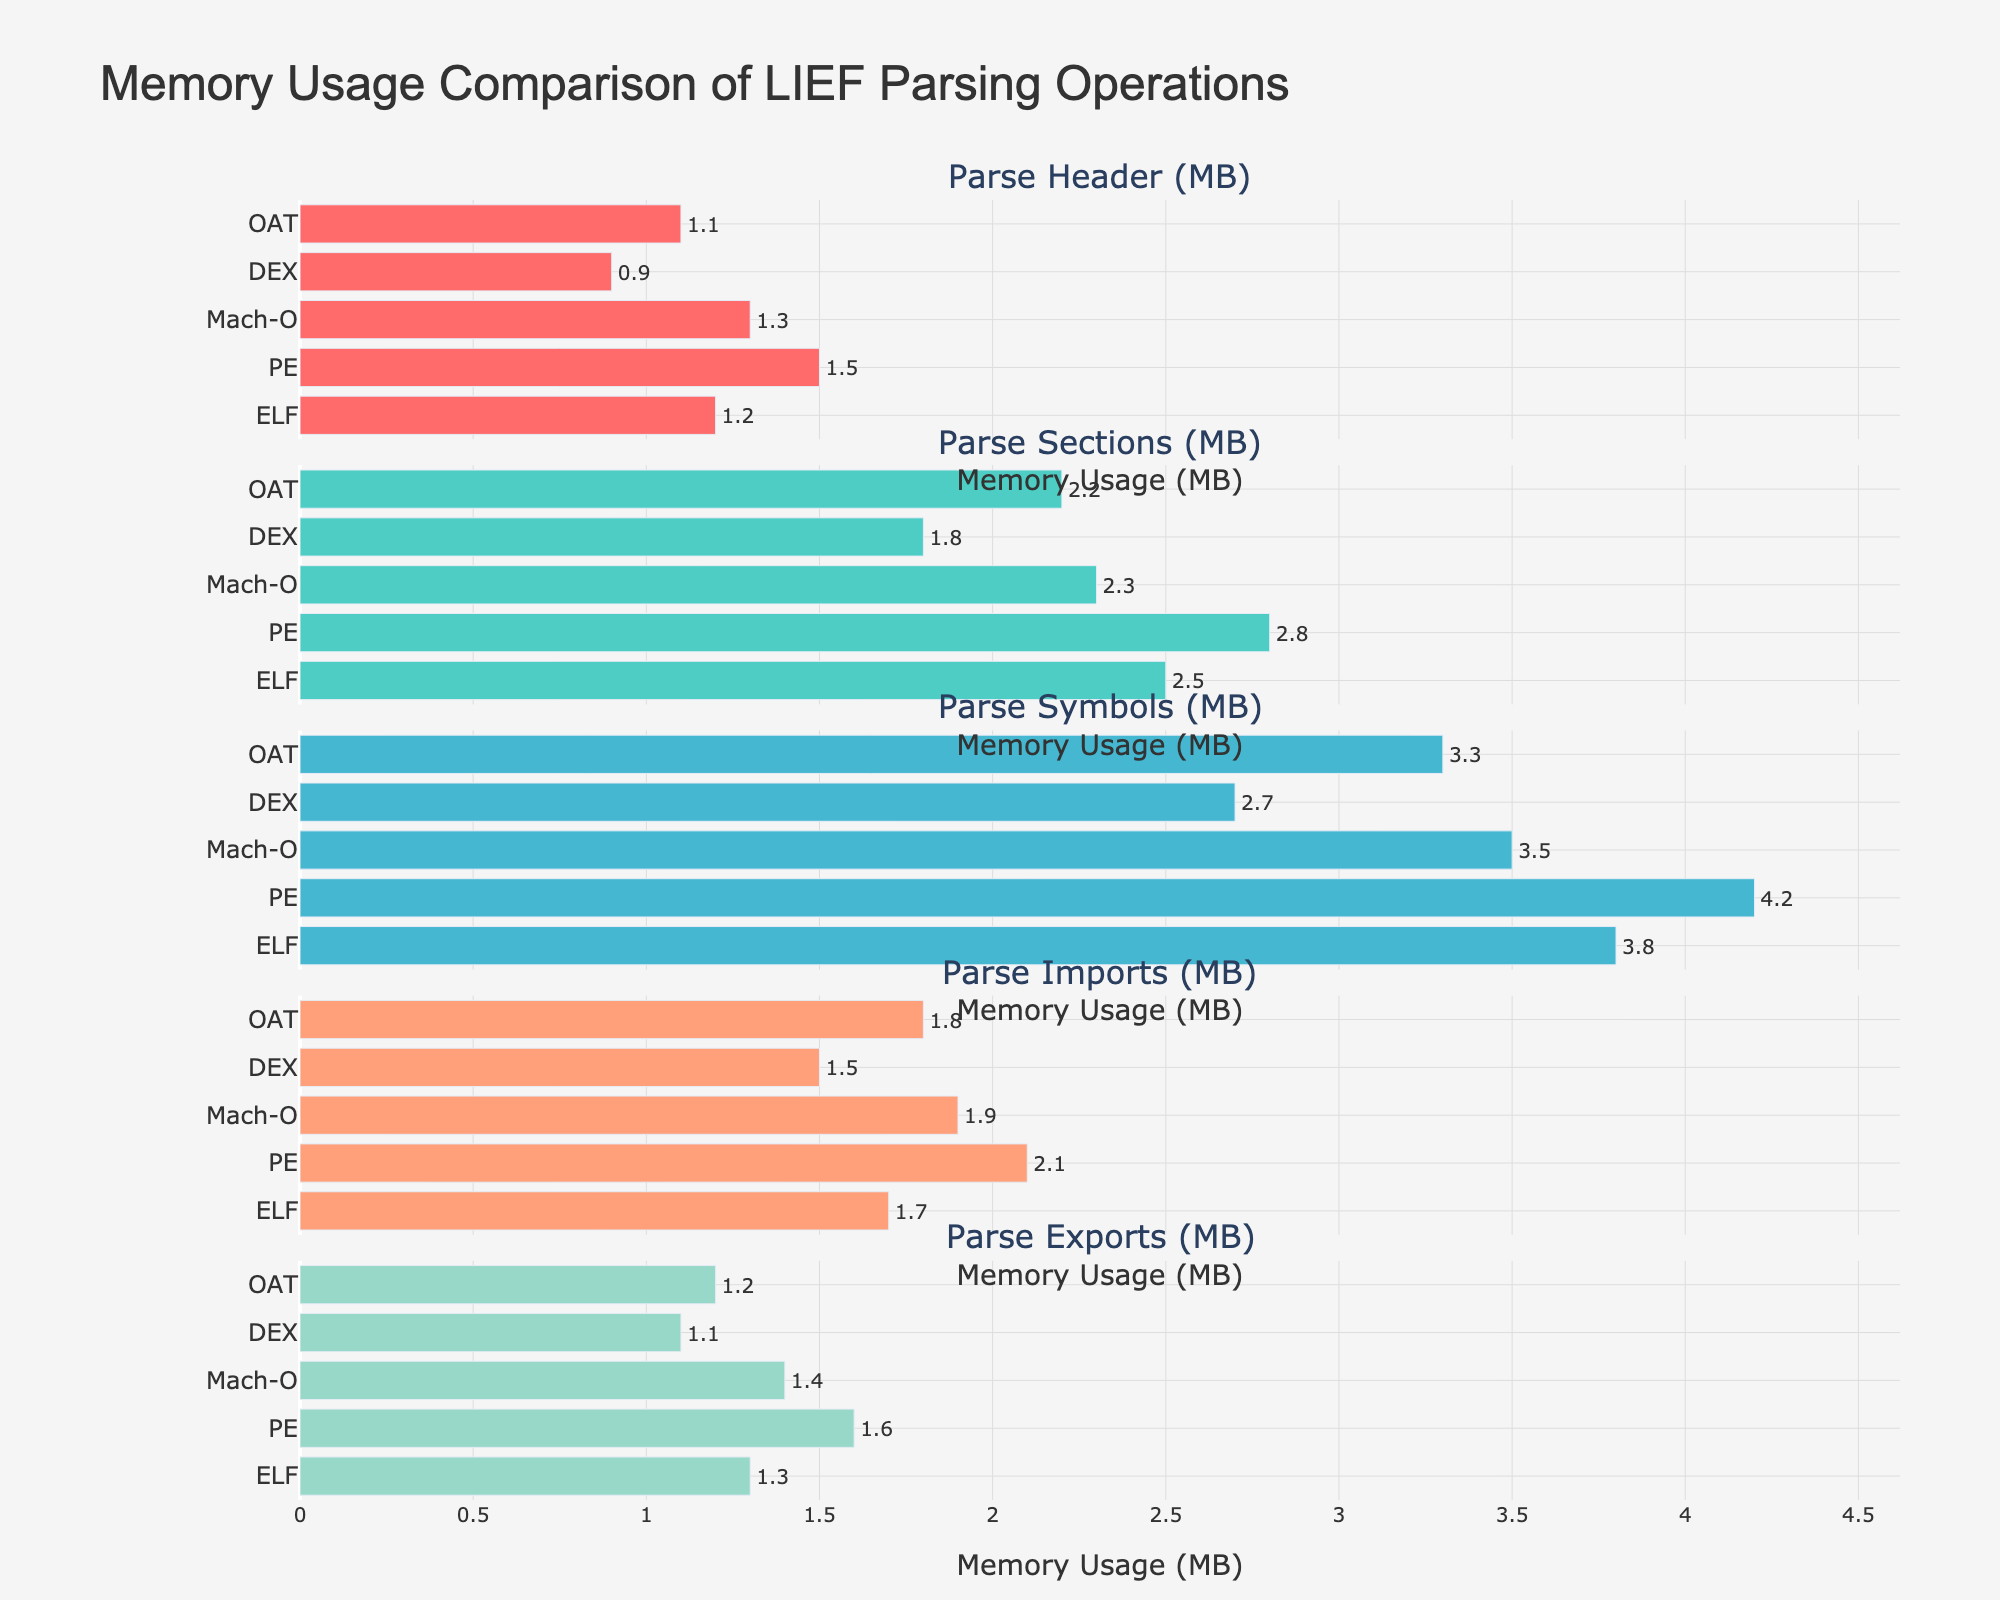What's the title of the figure? The title is located at the top of the figure and is displayed prominently.
Answer: Memory Usage Comparison of LIEF Parsing Operations Which file format has the lowest memory usage in the "Parse Sections" operation? Refer to the "Parse Sections" bar for each file format. The DEX format has the shortest bar, indicating the lowest memory usage.
Answer: DEX For the "Parse Symbols" operation, what is the average memory usage across all file formats? Add the memory usage for each file format in the "Parse Symbols" operation and divide by the number of file formats. (3.8 + 4.2 + 3.5 + 2.7 + 3.3) / 5 = 17.5 / 5.
Answer: 3.5 MB Which operation shows the highest memory usage for the PE file format? Look at each operation’s bar for PE and identify the longest bar. The "Parse Symbols" bar is the longest.
Answer: Parse Symbols How does the memory usage for parsing exports compare between ELF and Mach-O file formats? Compare the length of the "Parse Exports" bars for ELF and Mach-O. The Mach-O bar is slightly longer.
Answer: Mach-O is higher In the "Parse Imports" operation, what is the difference in memory usage between PE and DEX file formats? Subtract the memory usage for DEX from that for PE in the "Parse Imports" operation. 2.1 - 1.5 = 0.6.
Answer: 0.6 MB Which file format has a consistent memory usage pattern across all operations? Observe the bars across all operations for each file format to find the one with the least variation in length. Both ELF and Mach-O formats have relatively consistent bars, but ELF has slightly smaller variations.
Answer: ELF What is the total memory usage for the OAT file format across all operations? Sum the memory usage values for the OAT format in all operations. 1.1 + 2.2 + 3.3 + 1.8 + 1.2 = 9.6.
Answer: 9.6 MB If you were to rank the file formats based on their memory usage in the "Parse Header" operation, what would be the rank order? Compare the bar lengths in the "Parse Header" operation. PE > Mach-O > ELF > OAT > DEX based on the bar lengths.
Answer: PE, Mach-O, ELF, OAT, DEX How much more memory does the PE format use to parse symbols compared to parsing headers? Subtract the memory used for parsing headers from the memory used for parsing symbols in the PE format. 4.2 - 1.5 = 2.7.
Answer: 2.7 MB 